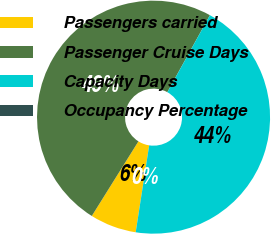Convert chart to OTSL. <chart><loc_0><loc_0><loc_500><loc_500><pie_chart><fcel>Passengers carried<fcel>Passenger Cruise Days<fcel>Capacity Days<fcel>Occupancy Percentage<nl><fcel>6.44%<fcel>49.15%<fcel>44.41%<fcel>0.0%<nl></chart> 